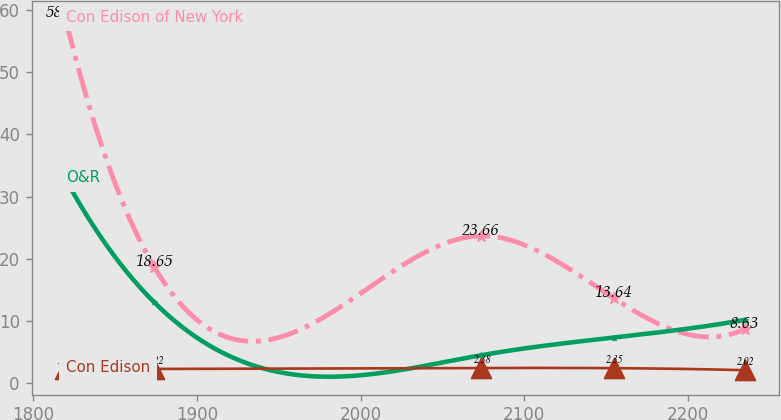Convert chart. <chart><loc_0><loc_0><loc_500><loc_500><line_chart><ecel><fcel>Con Edison of New York<fcel>O&R<fcel>Con Edison<nl><fcel>1819.61<fcel>58.69<fcel>32.82<fcel>2.19<nl><fcel>1873.86<fcel>18.65<fcel>12.96<fcel>2.22<nl><fcel>2073.92<fcel>23.66<fcel>4.44<fcel>2.38<nl><fcel>2154.82<fcel>13.64<fcel>7.28<fcel>2.35<nl><fcel>2234.81<fcel>8.63<fcel>10.12<fcel>2.02<nl></chart> 